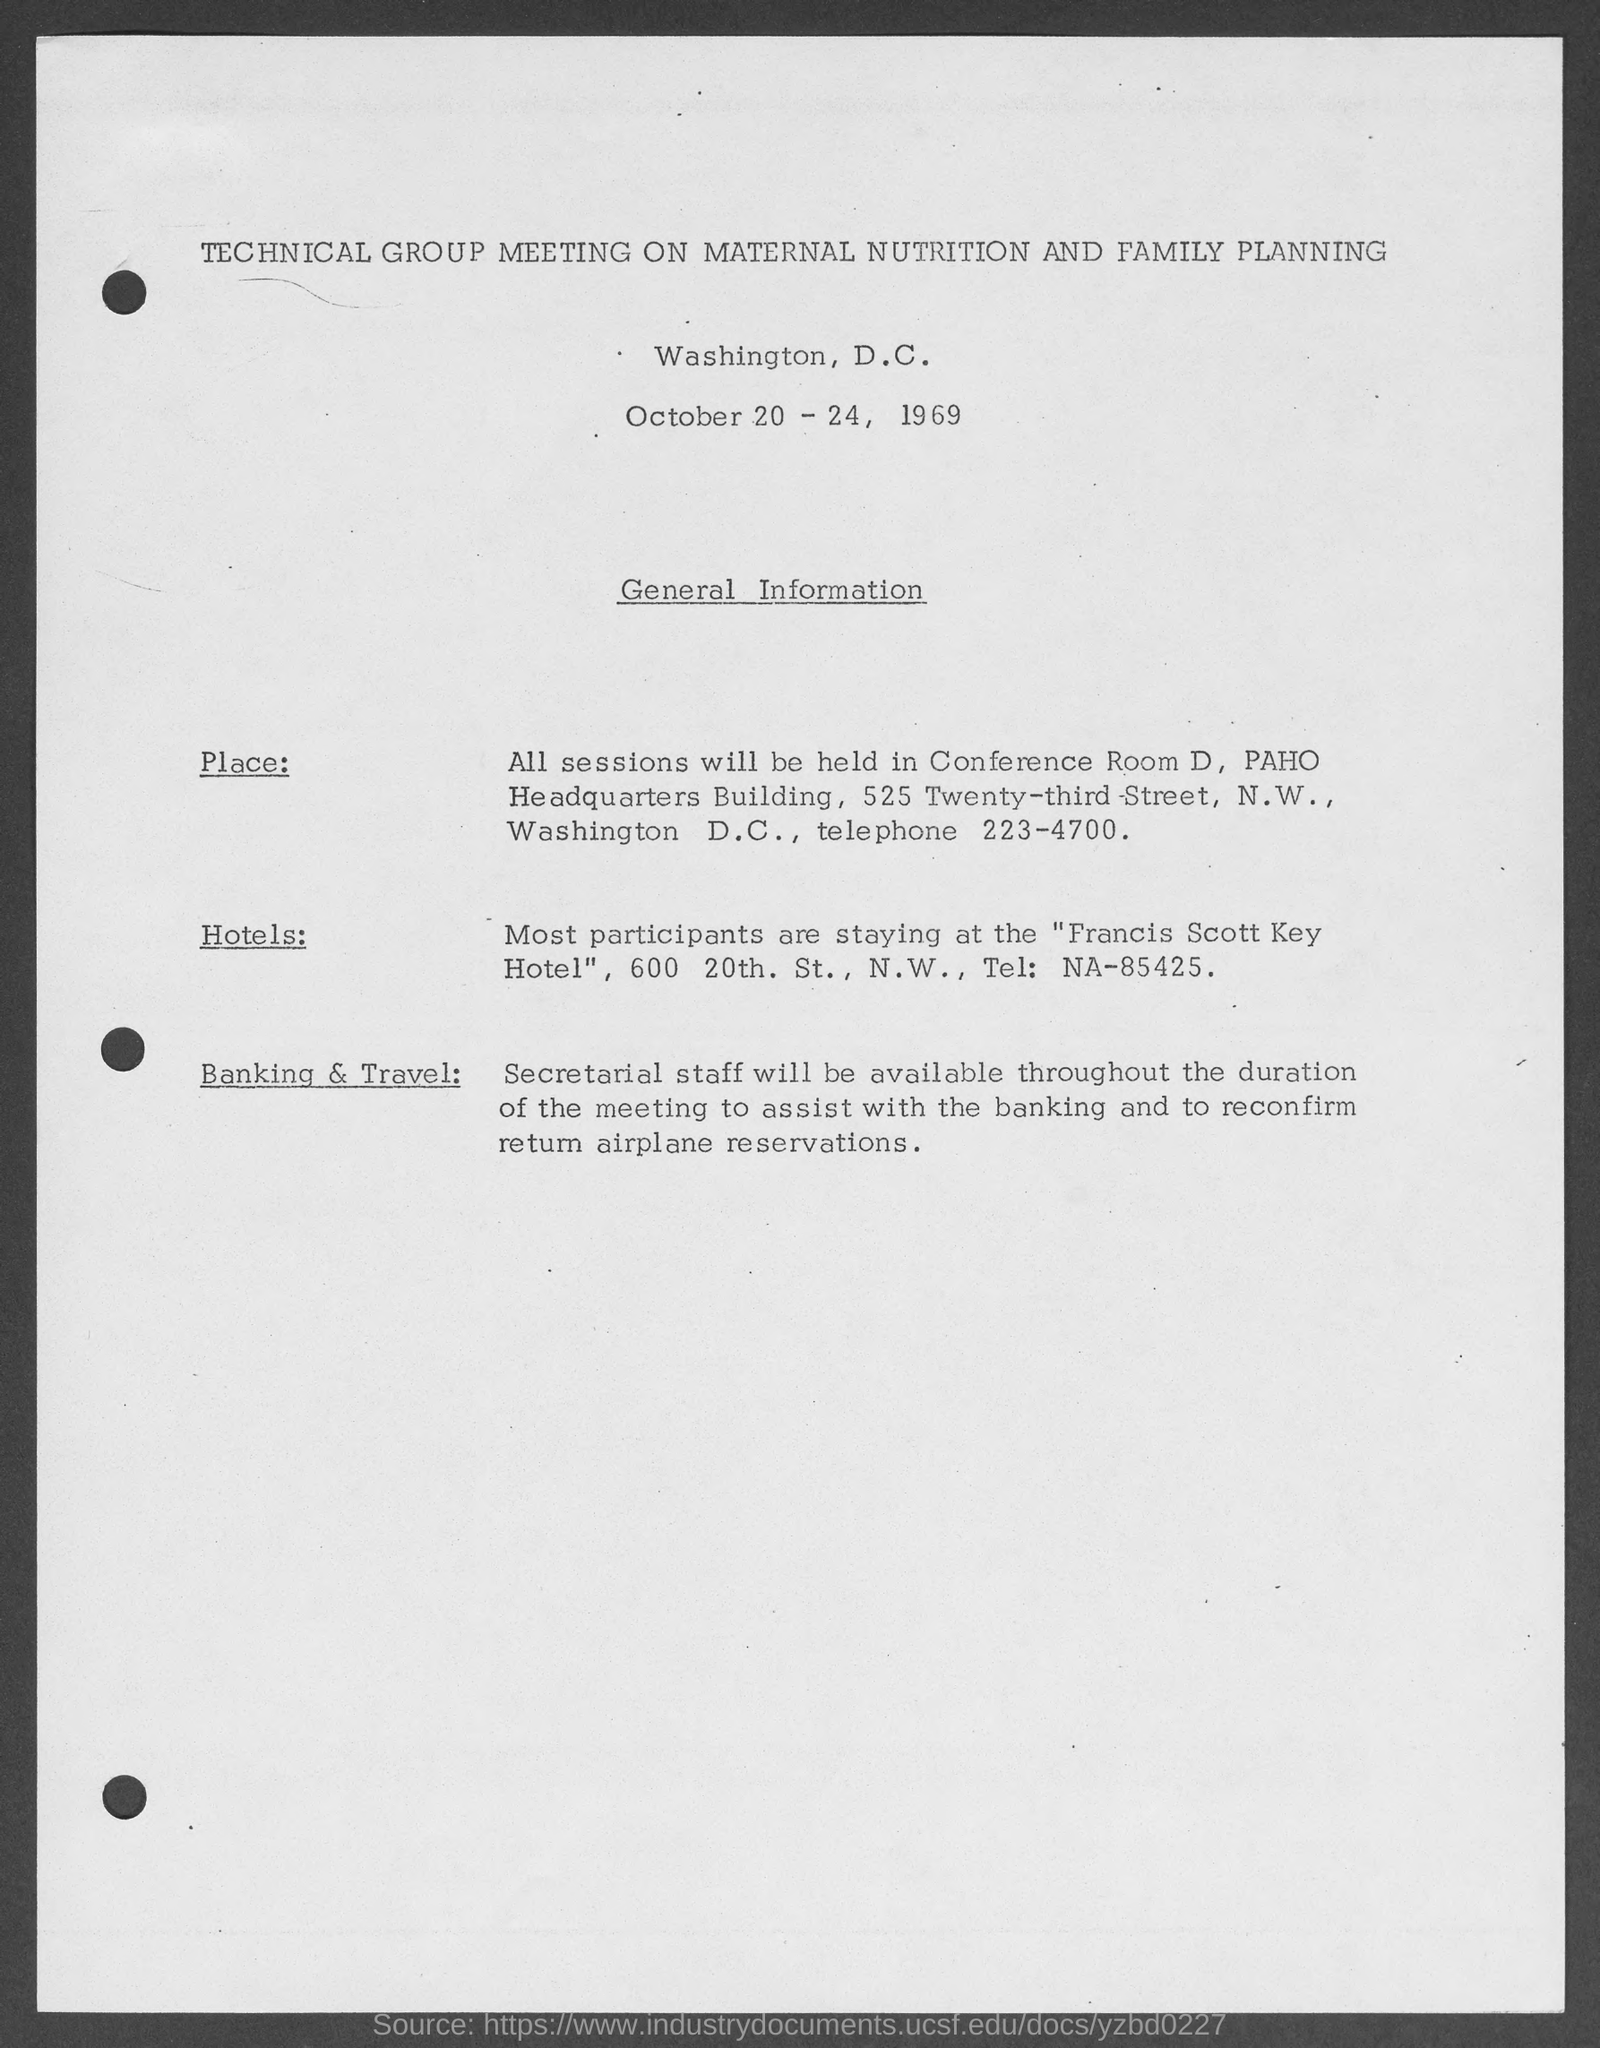Give some essential details in this illustration. The technical group meeting on maternal nutrition and family planning is scheduled to take place from October 20 to 24, 1969. The technical group meeting on maternal nutrition and family planning was held in Washington, D.C. It is expected that secretarial staff will be present and available throughout the duration of the meeting to assist with banking-related tasks and to confirm return airline reservations. 